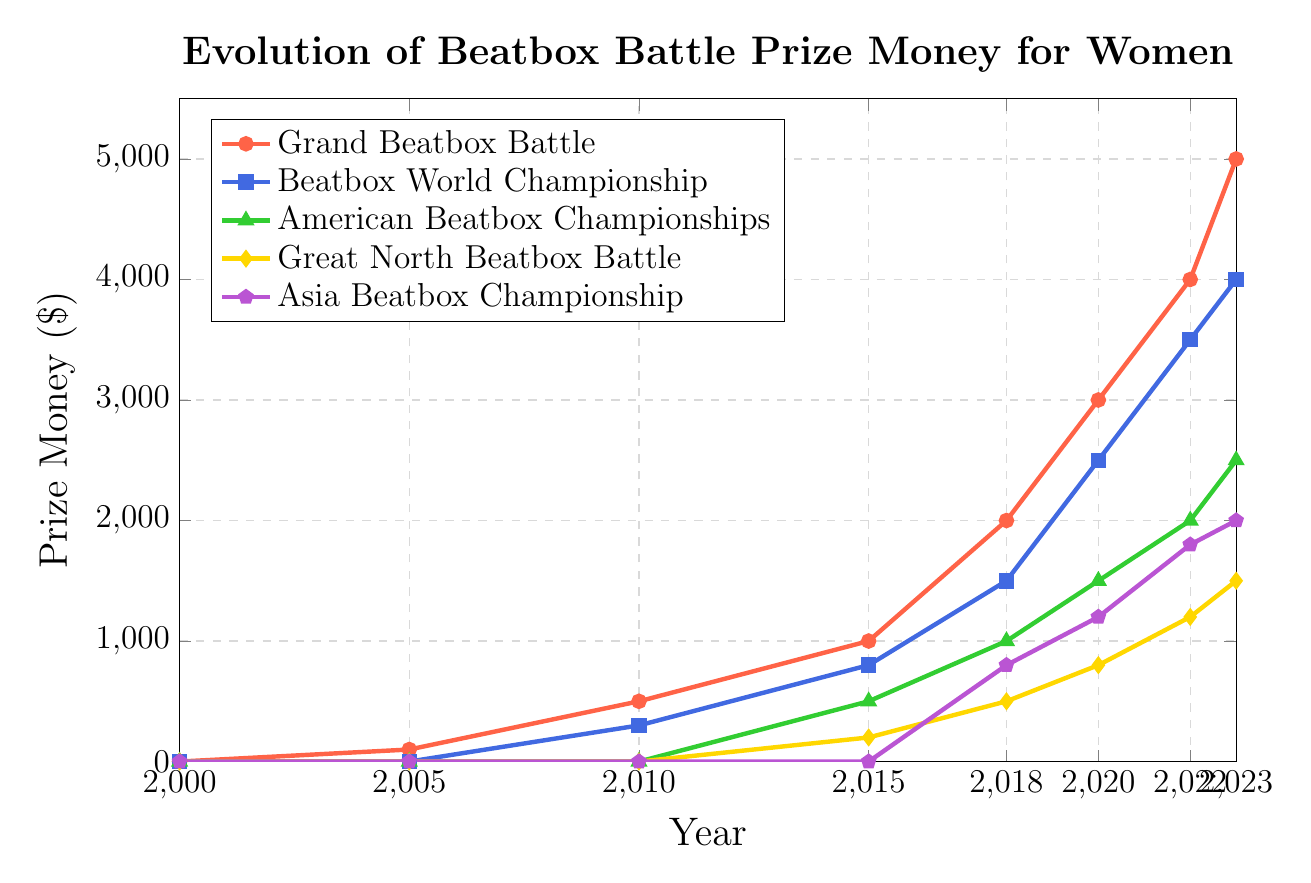Which year did the prize money for the Grand Beatbox Battle reach $3000? Look for the year on the x-axis where the prize money value for the Grand Beatbox Battle (red line) reaches $3000 on the y-axis.
Answer: 2020 Which event had the highest prize money in 2015? Compare the prize money for all events in the year 2015. The highest value is the Grand Beatbox Battle (red line) at $1000.
Answer: Grand Beatbox Battle By how much did the prize money for the Beatbox World Championship increase from 2018 to 2020? Check the values for the Beatbox World Championship (blue line) in 2018 and 2020, and calculate the difference: $2500 - $1500 = $1000.
Answer: $1000 Which event had the lowest prize money in 2018? Look at the prize money values for all events in 2018 and identify the lowest one, which is the Great North Beatbox Battle (yellow line) at $500.
Answer: Great North Beatbox Battle How many years after the start (2000) did the Asia Beatbox Championship start offering prize money? Find the first year the Asia Beatbox Championship (purple line) offers prize money, which is 2018. Subtract 2000 from 2018 to find the difference: 2018 - 2000 = 18 years.
Answer: 18 years What is the total prize money offered by the American Beatbox Championships from 2015 to 2023? Add the prize money for the American Beatbox Championships (green line) from 2015 to 2023: $500 (2015) + $1000 (2018) + $1500 (2020) + $2000 (2022) + $2500 (2023) = $7500.
Answer: $7500 How many events had a prize money of at least $2000 in 2022? Check the prize money values for all events in 2022 and count the ones with at least $2000: Grand Beatbox Battle ($4000), Beatbox World Championship ($3500), American Beatbox Championships ($2000), Asia Beatbox Championship ($1800). Only the first three qualify.
Answer: 3 events Between 2020 and 2023, which event saw the smallest increase in prize money? Calculate the increase in prize money for each event between 2020 and 2023 and identify the smallest: Grand Beatbox Battle ($5000 - $3000 = $2000), Beatbox World Championship ($4000 - $2500 = $1500), American Beatbox Championships ($2500 - $1500 = $1000), Great North Beatbox Battle ($1500 - $800 = $700), Asia Beatbox Championship ($2000 - $1200 = $800). The Great North Beatbox Battle has the smallest increase.
Answer: Great North Beatbox Battle Which year showed the biggest jump in prize money for the Grand Beatbox Battle? Compare the differences in prize money for the Grand Beatbox Battle (red line) between consecutive years and identify the biggest: $3000 (2020) - $2000 (2018) = $1000, $4000 (2022) - $3000 (2020) = $1000, $5000 (2023) - $4000 (2022) = $1000, etc. The biggest jump of $1000 occurs between multiple periods, such as 2018 to 2020.
Answer: 2018-2020 Is there any year where all events offered exactly $0 in prize money? Check the prize money values for all events in each year. In 2000 and 2005, all values are $0. Choose one.
Answer: 2000 